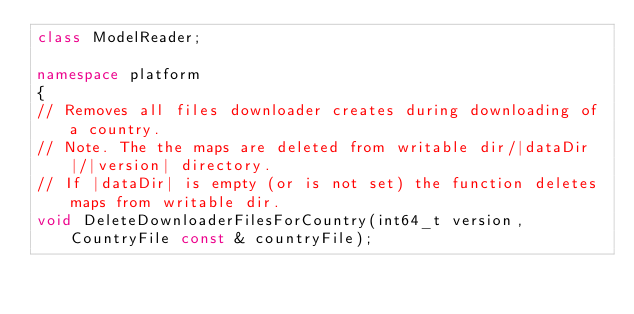<code> <loc_0><loc_0><loc_500><loc_500><_C++_>class ModelReader;

namespace platform
{
// Removes all files downloader creates during downloading of a country.
// Note. The the maps are deleted from writable dir/|dataDir|/|version| directory.
// If |dataDir| is empty (or is not set) the function deletes maps from writable dir.
void DeleteDownloaderFilesForCountry(int64_t version, CountryFile const & countryFile);</code> 